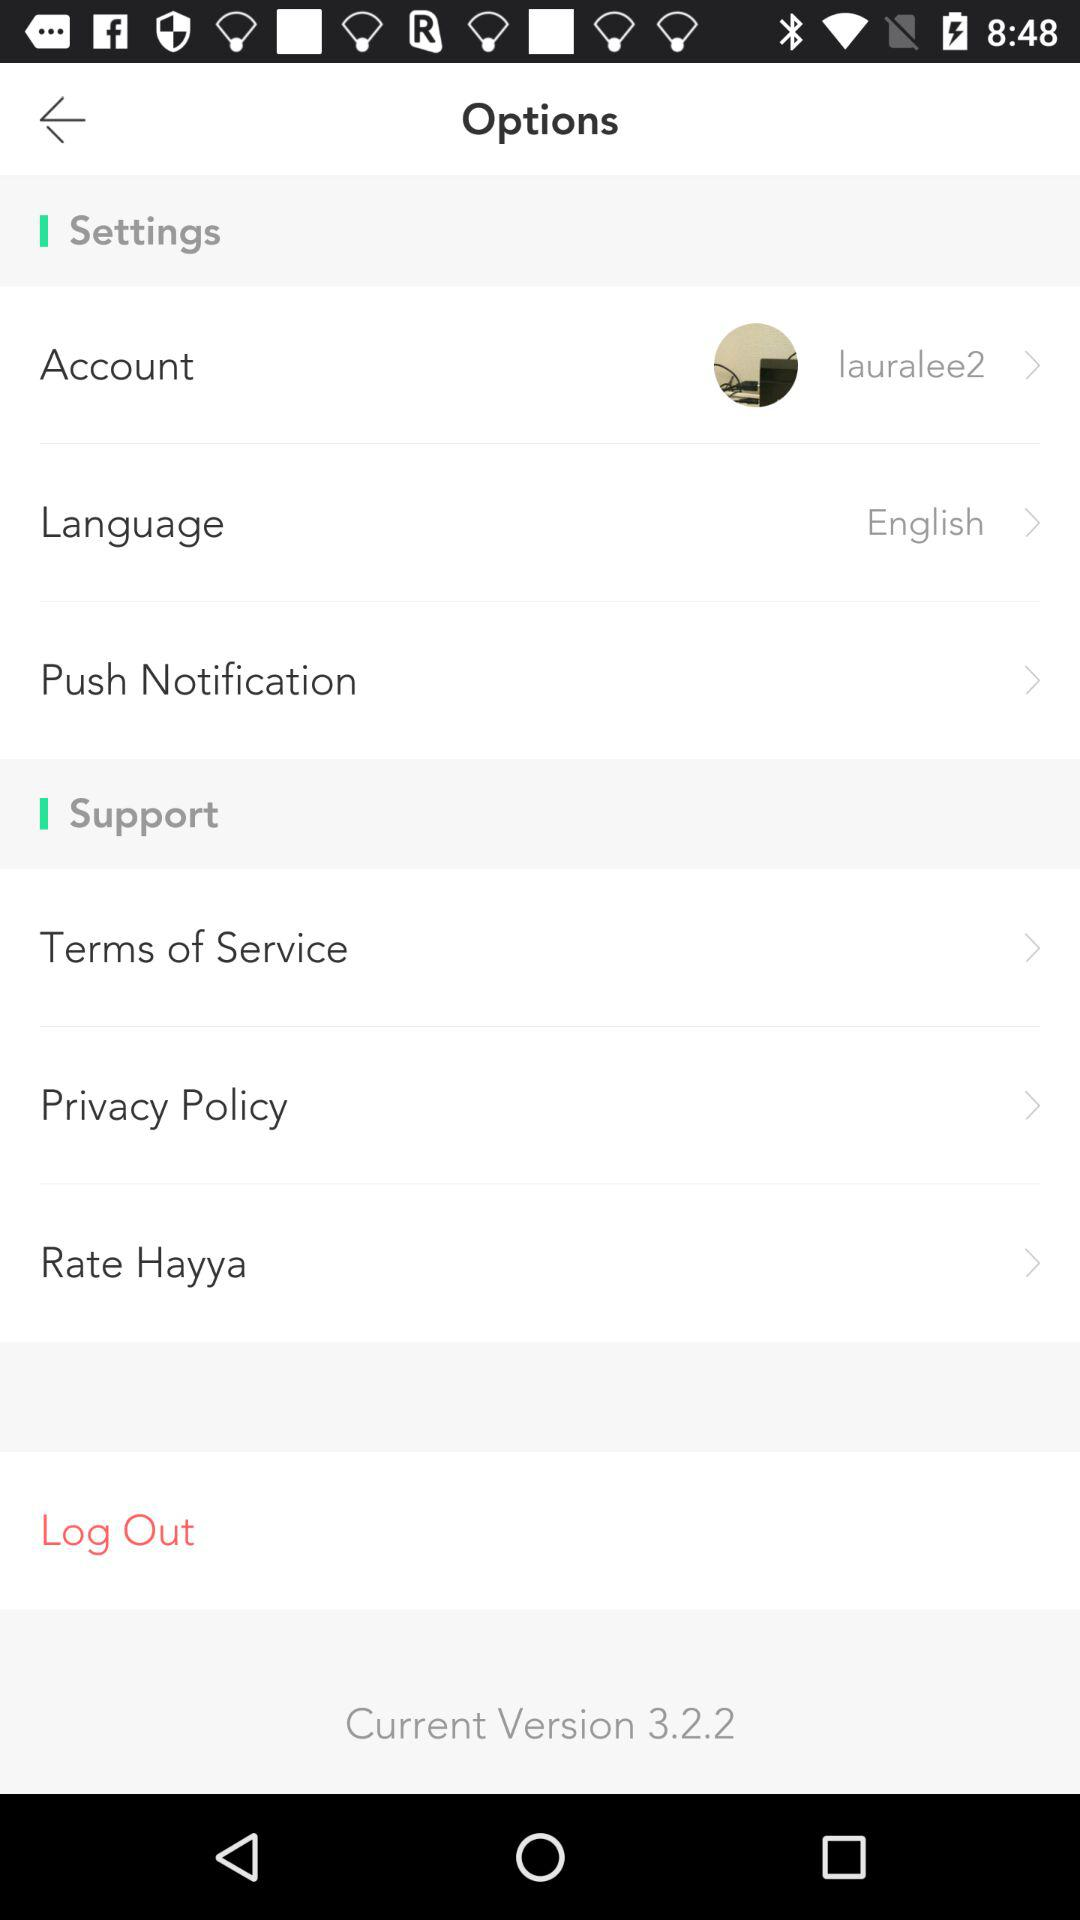What is the language? The language is English. 